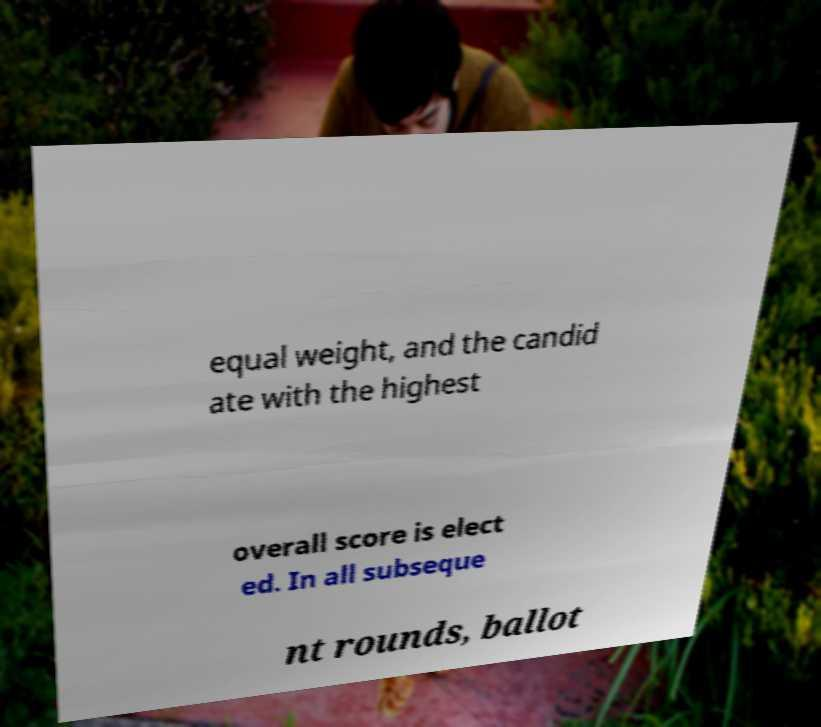What messages or text are displayed in this image? I need them in a readable, typed format. equal weight, and the candid ate with the highest overall score is elect ed. In all subseque nt rounds, ballot 